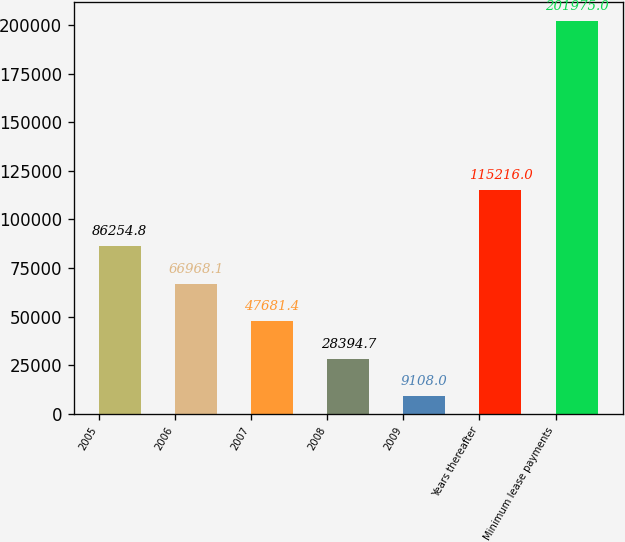Convert chart. <chart><loc_0><loc_0><loc_500><loc_500><bar_chart><fcel>2005<fcel>2006<fcel>2007<fcel>2008<fcel>2009<fcel>Years thereafter<fcel>Minimum lease payments<nl><fcel>86254.8<fcel>66968.1<fcel>47681.4<fcel>28394.7<fcel>9108<fcel>115216<fcel>201975<nl></chart> 